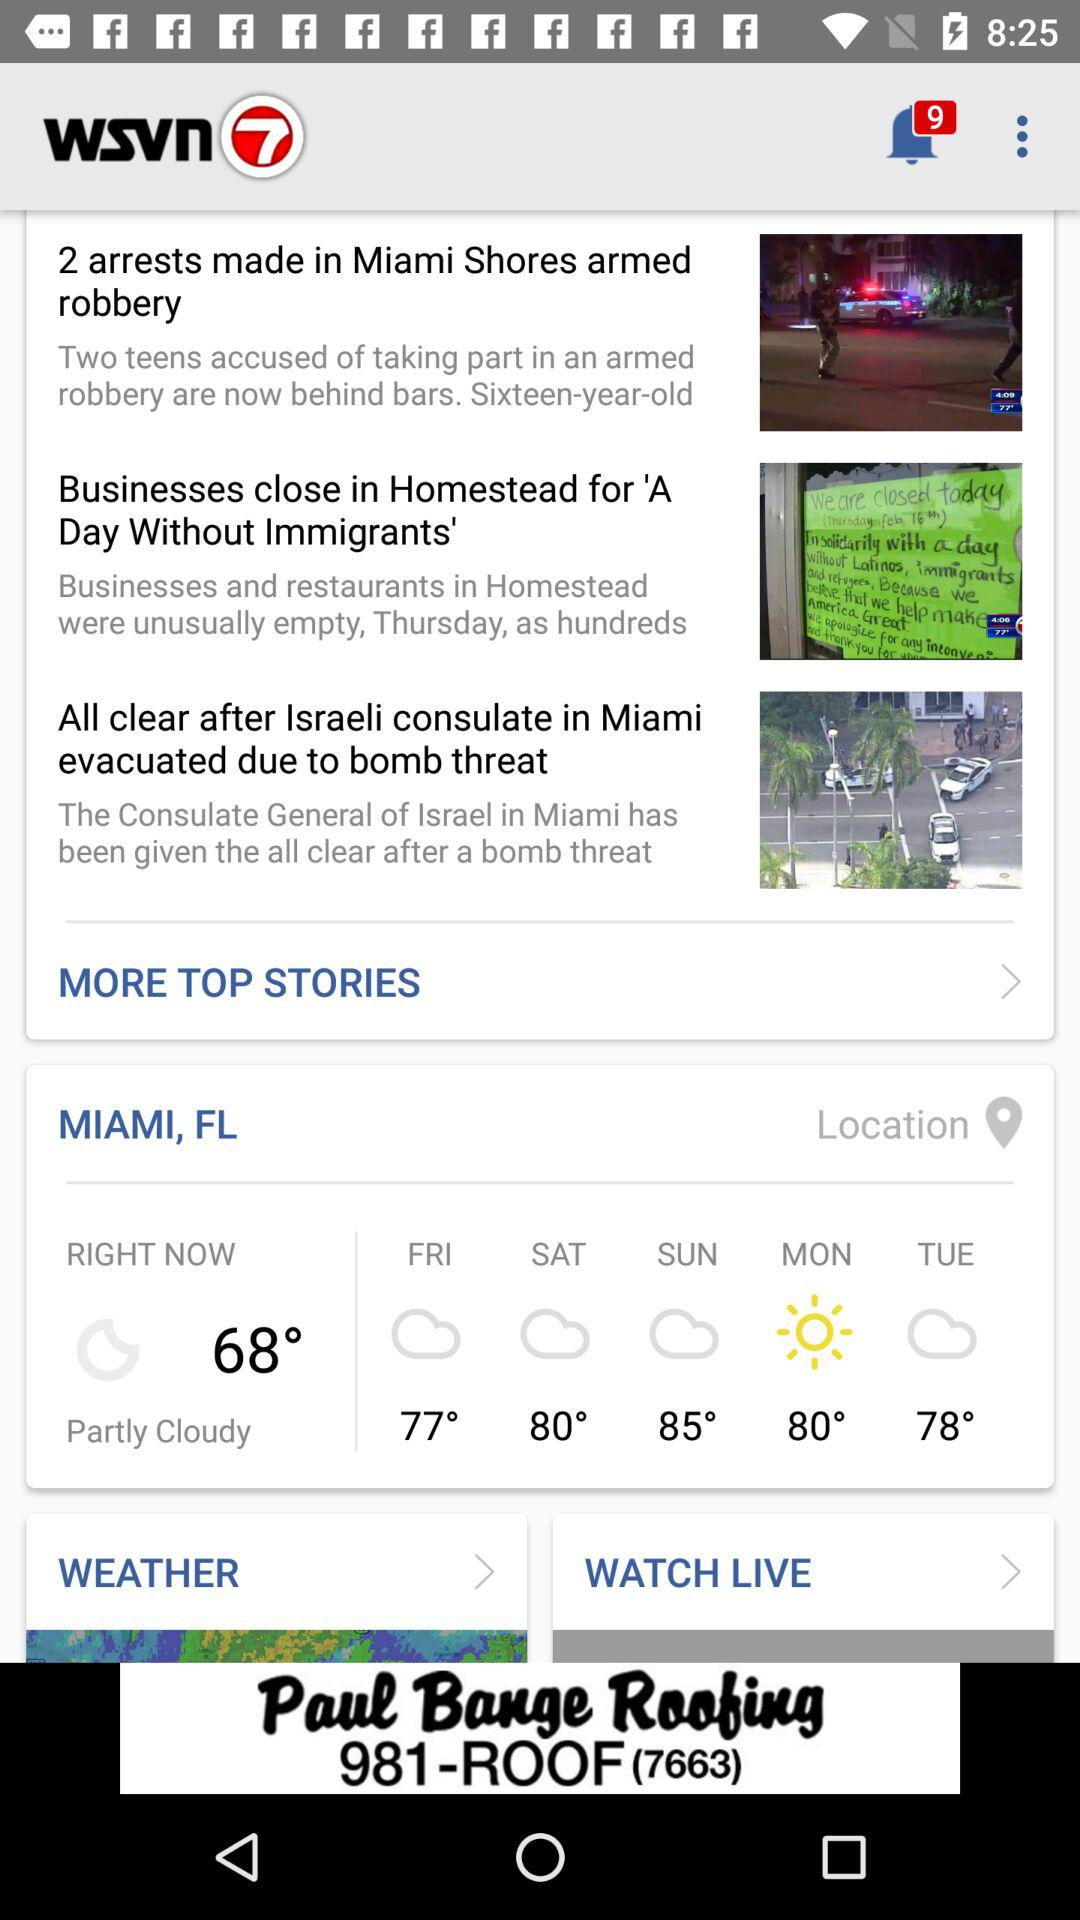On which day will the temperature reach 78 degrees Celsius? The temperature will reach 78 degrees Celsius on Tuesday. 